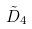Convert formula to latex. <formula><loc_0><loc_0><loc_500><loc_500>\tilde { D } _ { 4 }</formula> 